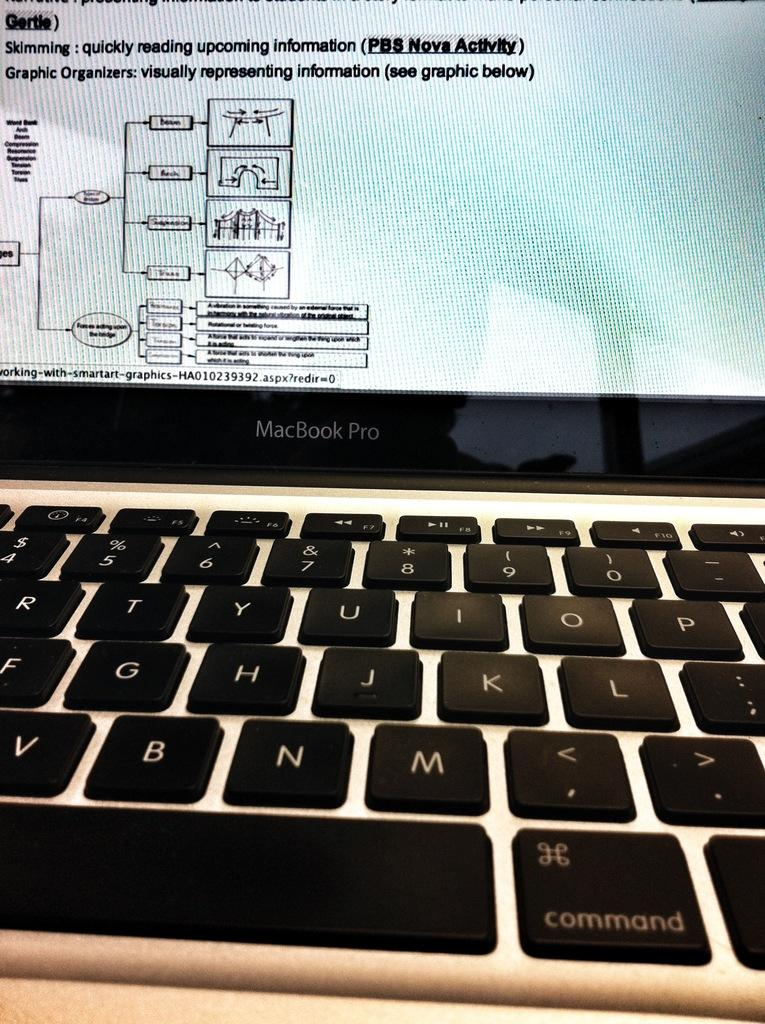<image>
Describe the image concisely. MacBook Pro laptop with a key called command near the bottom. 